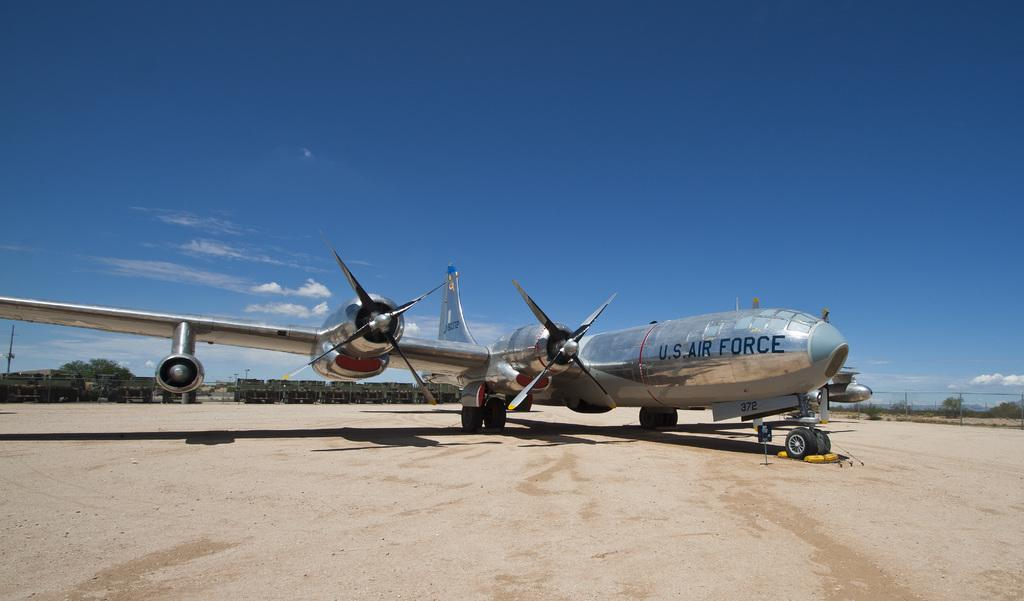<image>
Relay a brief, clear account of the picture shown. A US air force plane on a dusty ground 